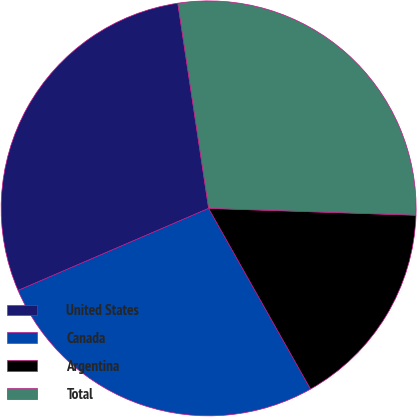<chart> <loc_0><loc_0><loc_500><loc_500><pie_chart><fcel>United States<fcel>Canada<fcel>Argentina<fcel>Total<nl><fcel>29.1%<fcel>26.7%<fcel>16.3%<fcel>27.9%<nl></chart> 